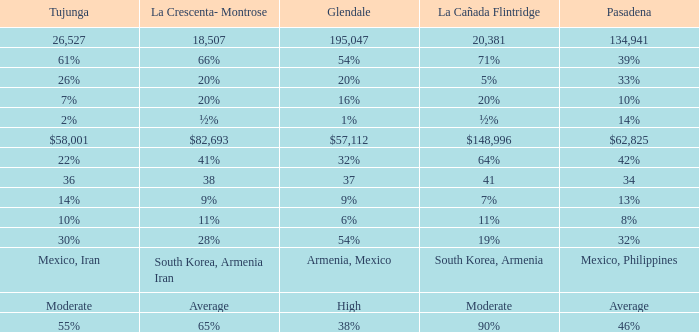What is the fraction of tujunja when pasadena represents 33%? 26%. Can you parse all the data within this table? {'header': ['Tujunga', 'La Crescenta- Montrose', 'Glendale', 'La Cañada Flintridge', 'Pasadena'], 'rows': [['26,527', '18,507', '195,047', '20,381', '134,941'], ['61%', '66%', '54%', '71%', '39%'], ['26%', '20%', '20%', '5%', '33%'], ['7%', '20%', '16%', '20%', '10%'], ['2%', '½%', '1%', '½%', '14%'], ['$58,001', '$82,693', '$57,112', '$148,996', '$62,825'], ['22%', '41%', '32%', '64%', '42%'], ['36', '38', '37', '41', '34'], ['14%', '9%', '9%', '7%', '13%'], ['10%', '11%', '6%', '11%', '8%'], ['30%', '28%', '54%', '19%', '32%'], ['Mexico, Iran', 'South Korea, Armenia Iran', 'Armenia, Mexico', 'South Korea, Armenia', 'Mexico, Philippines'], ['Moderate', 'Average', 'High', 'Moderate', 'Average'], ['55%', '65%', '38%', '90%', '46%']]} 